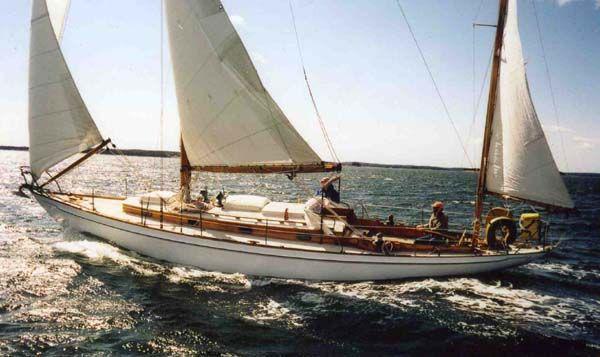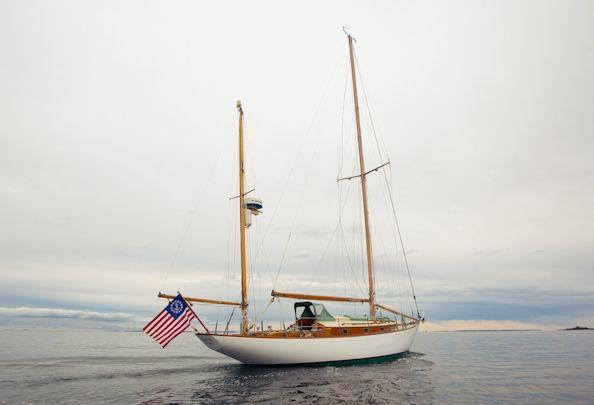The first image is the image on the left, the second image is the image on the right. For the images shown, is this caption "There is an American flag visible on a sail boat." true? Answer yes or no. Yes. 